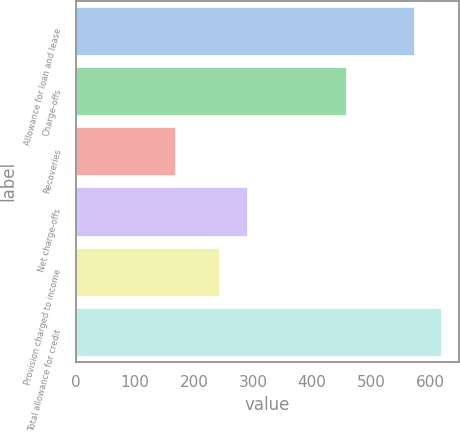Convert chart to OTSL. <chart><loc_0><loc_0><loc_500><loc_500><bar_chart><fcel>Allowance for loan and lease<fcel>Charge-offs<fcel>Recoveries<fcel>Net charge-offs<fcel>Provision charged to income<fcel>Total allowance for credit<nl><fcel>573<fcel>457<fcel>168<fcel>289<fcel>242<fcel>618.2<nl></chart> 